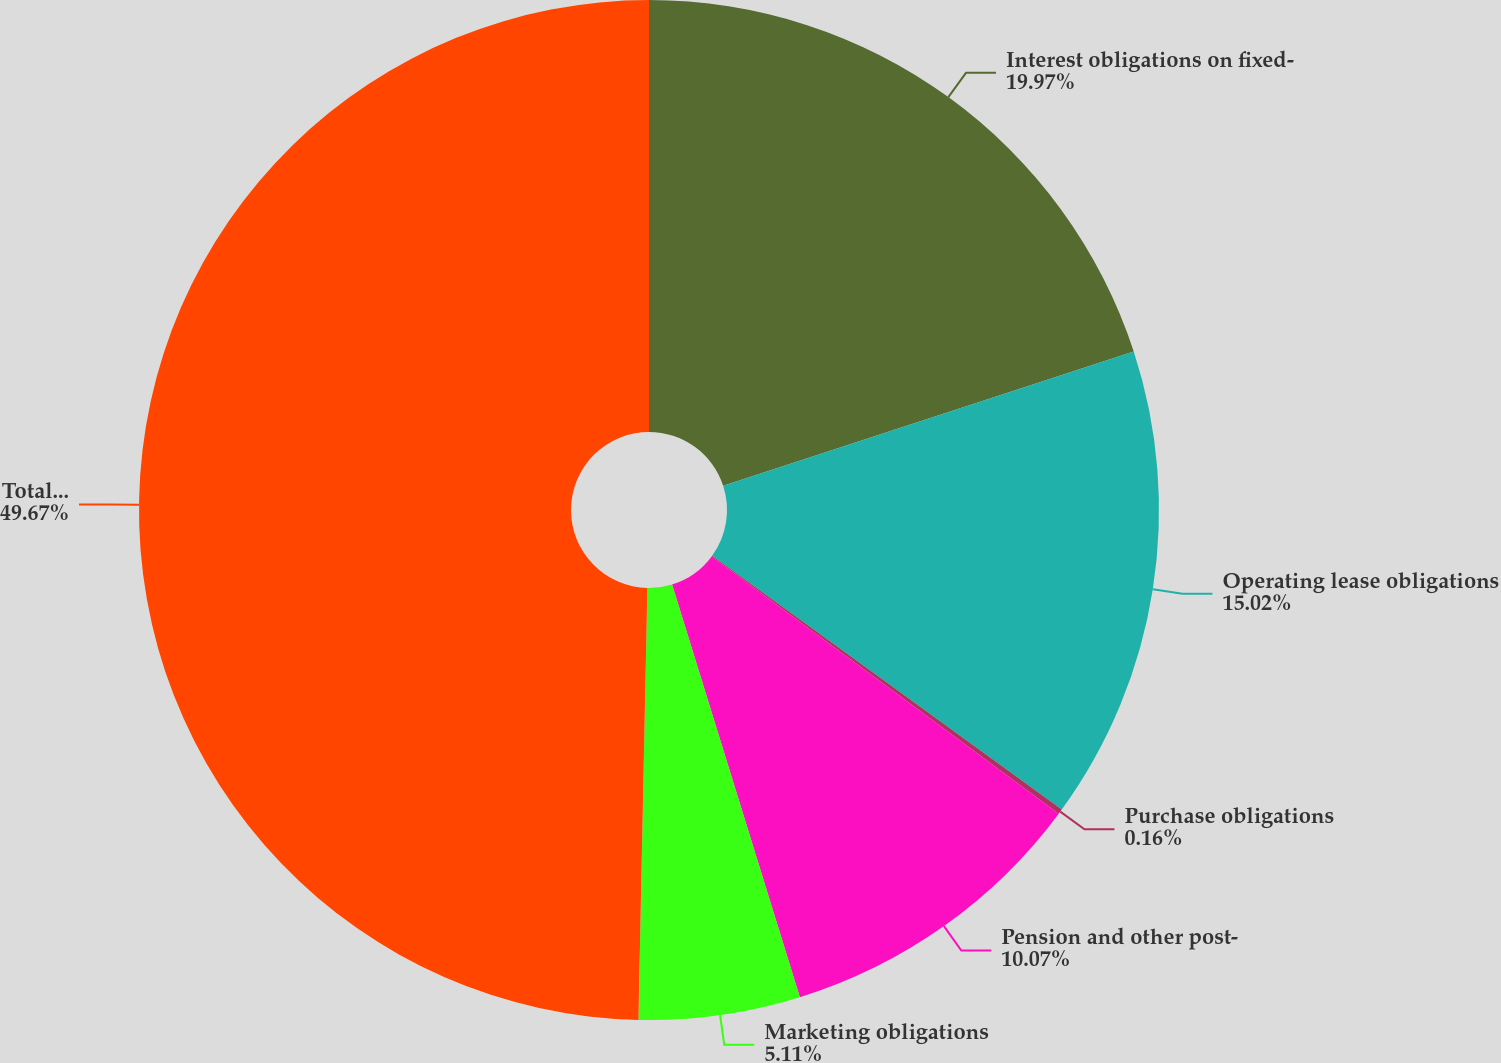Convert chart to OTSL. <chart><loc_0><loc_0><loc_500><loc_500><pie_chart><fcel>Interest obligations on fixed-<fcel>Operating lease obligations<fcel>Purchase obligations<fcel>Pension and other post-<fcel>Marketing obligations<fcel>Total contractual obligations<nl><fcel>19.97%<fcel>15.02%<fcel>0.16%<fcel>10.07%<fcel>5.11%<fcel>49.67%<nl></chart> 